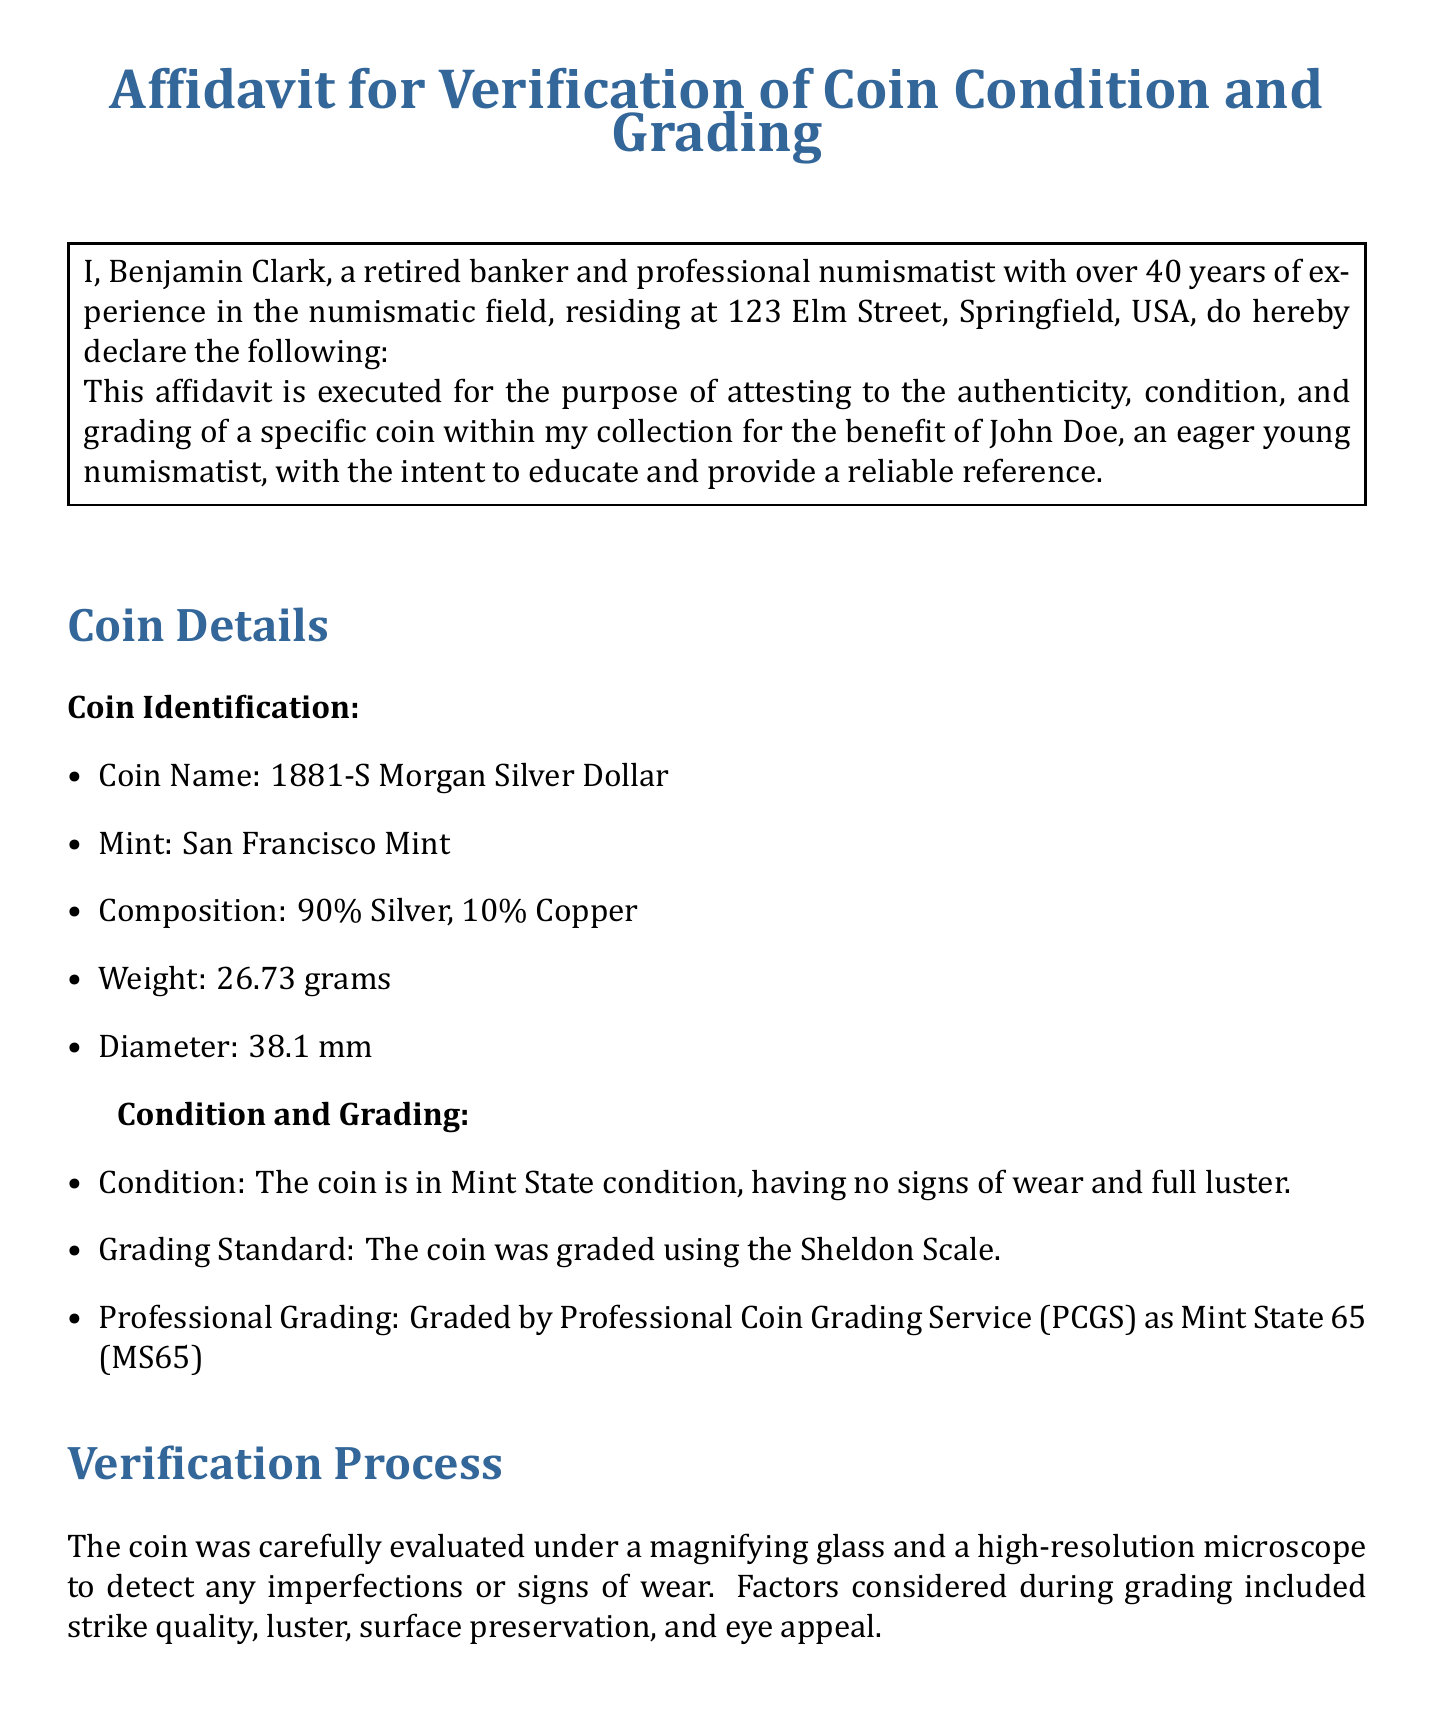What is the name of the coin? The name of the coin is explicitly stated in the document under Coin Identification.
Answer: 1881-S Morgan Silver Dollar Who graded the coin? The document names the Professional Coin Grading Service (PCGS) as the entity that graded the coin.
Answer: Professional Coin Grading Service (PCGS) What is the weight of the coin? The weight is specified in the Coin Details section of the affidavit.
Answer: 26.73 grams What is the date of the affidavit? The date is found at the end of the document, preceding Benjamin Clark's signature.
Answer: October 15, 2023 What is the estimated value of the coin? The estimated value is mentioned in the Expert Opinion section as per the latest reference.
Answer: $300 What grading standard was used? The grading standard is clearly stated in the Condition and Grading section.
Answer: Sheldon Scale What is the condition of the coin? The condition is detailed in the Condition and Grading section of the affidavit.
Answer: Mint State Why was the affidavit executed? The purpose of the affidavit is outlined in the introduction part of the document.
Answer: To attest to the authenticity, condition, and grading of a specific coin for education How many years of experience does Benjamin Clark have? The document states the number of years of experience explicitly near the beginning.
Answer: 40 years 